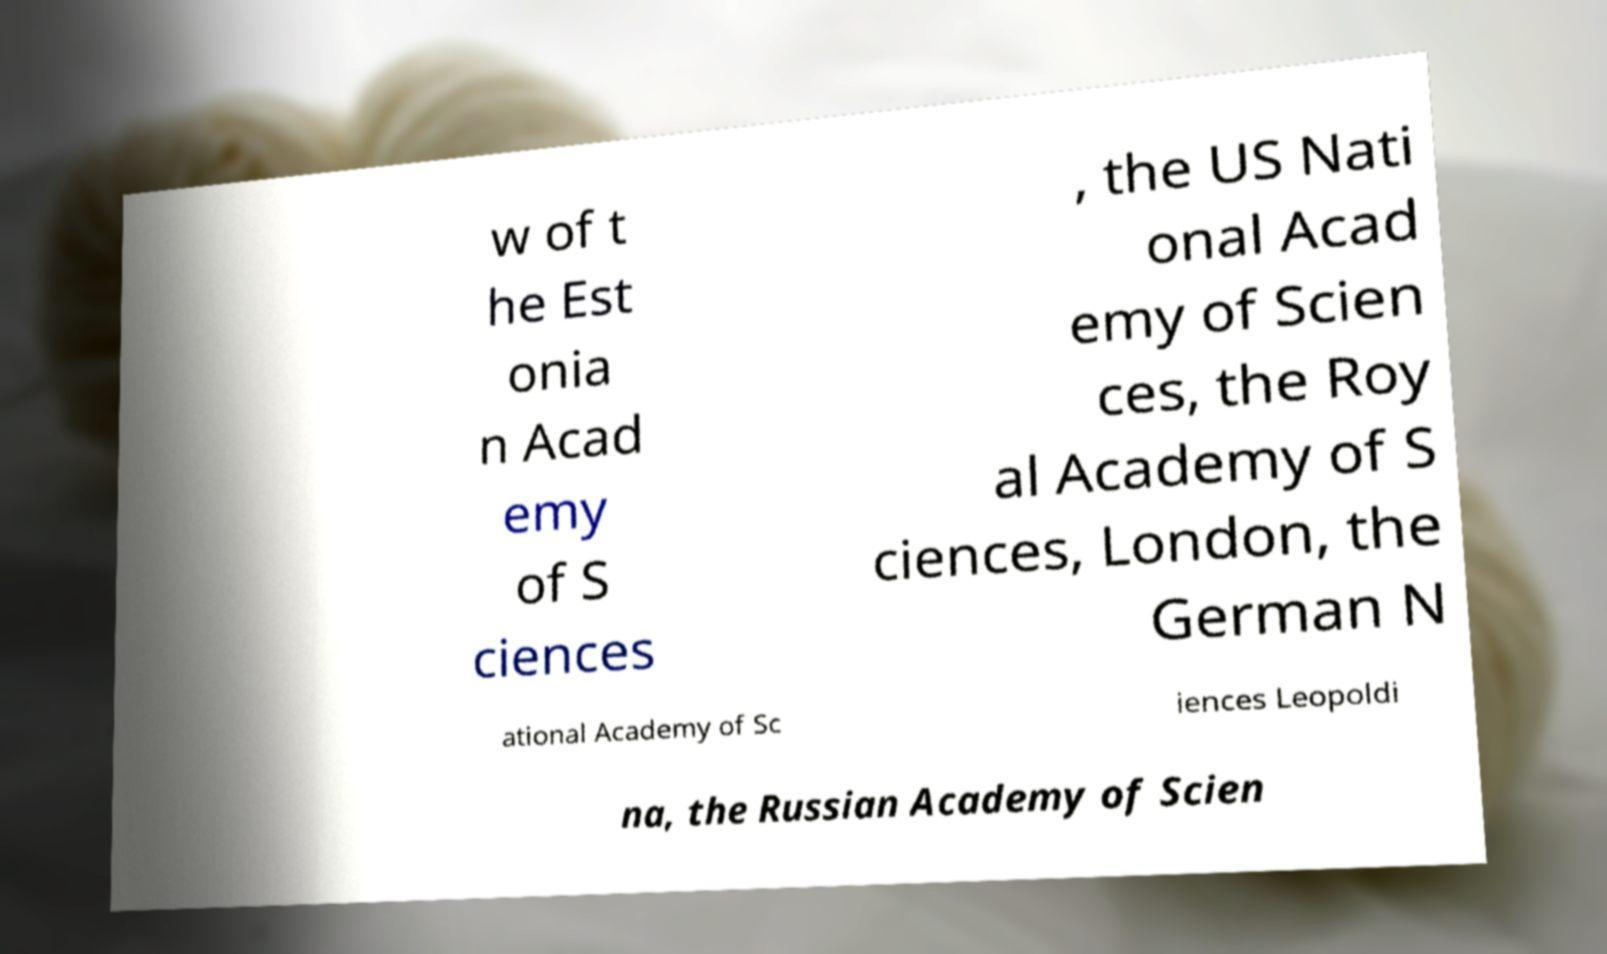Could you extract and type out the text from this image? w of t he Est onia n Acad emy of S ciences , the US Nati onal Acad emy of Scien ces, the Roy al Academy of S ciences, London, the German N ational Academy of Sc iences Leopoldi na, the Russian Academy of Scien 